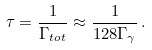<formula> <loc_0><loc_0><loc_500><loc_500>\tau = \frac { 1 } { \Gamma _ { t o t } } \approx \frac { 1 } { 1 2 8 \Gamma _ { \gamma } } \, .</formula> 